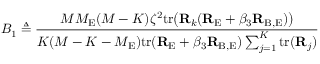<formula> <loc_0><loc_0><loc_500><loc_500>B _ { 1 } \triangle q \frac { M M _ { E } ( M - K ) \zeta ^ { 2 } t r \left ( { R } _ { k } ( { R } _ { E } + \beta _ { 3 } { R } _ { B , E } ) \right ) } { K ( M - K - M _ { E } ) t r ( { R } _ { E } + \beta _ { 3 } { R } _ { B , E } ) \sum _ { j = 1 } ^ { K } t r ( { R } _ { j } ) }</formula> 